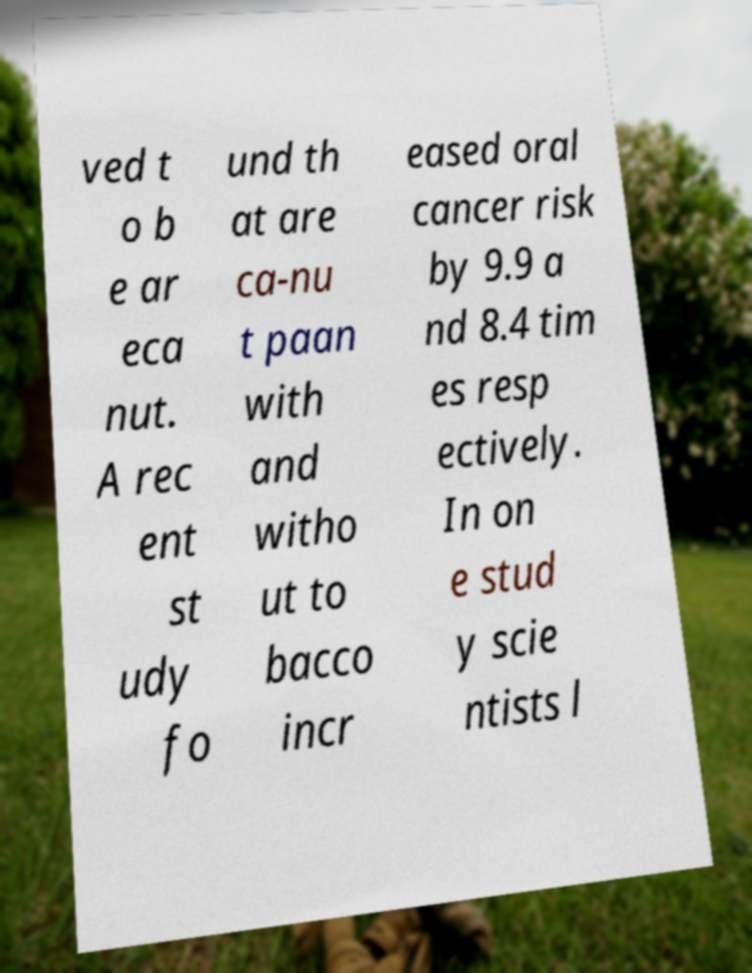Can you read and provide the text displayed in the image?This photo seems to have some interesting text. Can you extract and type it out for me? ved t o b e ar eca nut. A rec ent st udy fo und th at are ca-nu t paan with and witho ut to bacco incr eased oral cancer risk by 9.9 a nd 8.4 tim es resp ectively. In on e stud y scie ntists l 